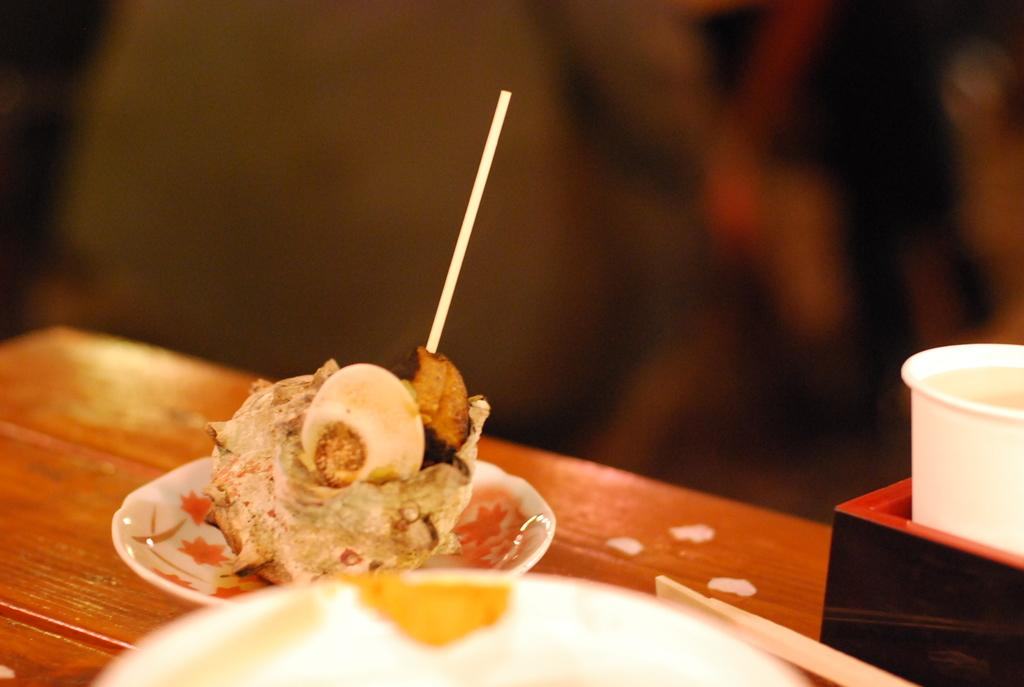What type of food is on the plate in the image? There is a dessert with a stick on a plate in the image. What else can be seen on the table in the image? There is a glass on the table in the image. What is the dessert resting on in the image? The dessert is on a plate in the image. Can you describe the background of the image? The background of the image is blurred. What type of tools does the fireman have in the image? There are no firemen or tools present in the image; it features a dessert with a stick on a plate, a glass, and a blurred background. 